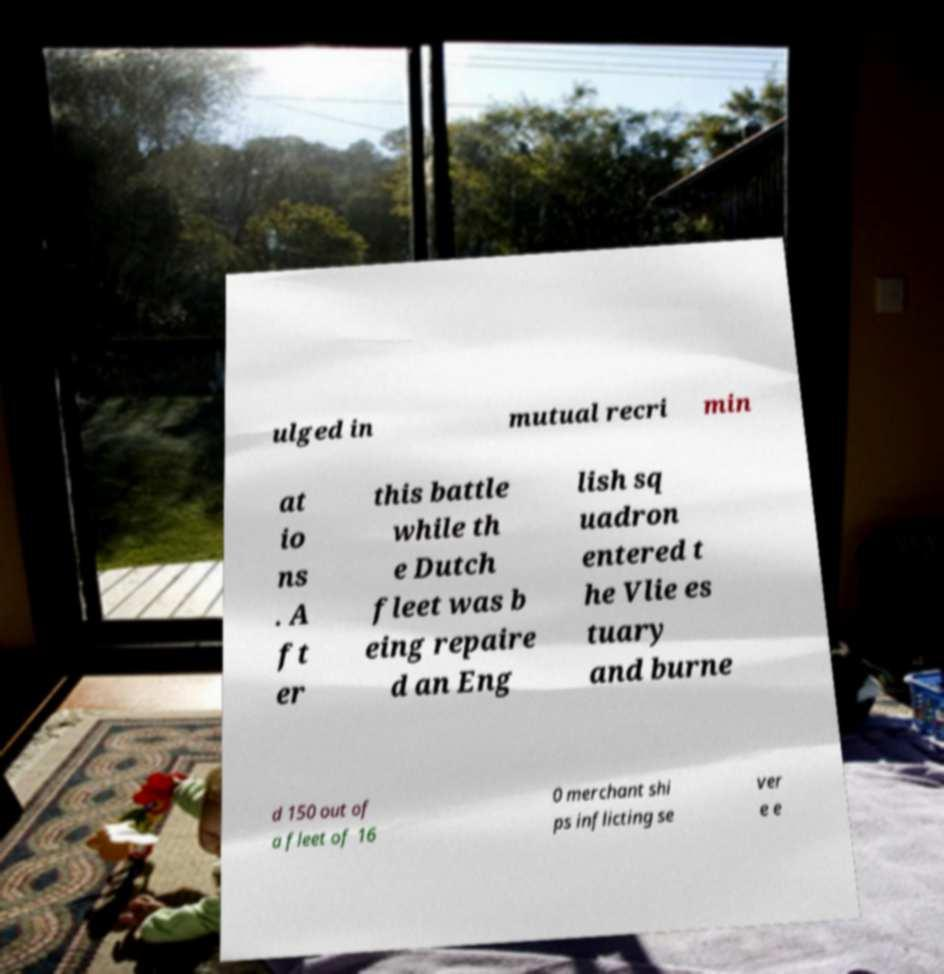Please read and relay the text visible in this image. What does it say? ulged in mutual recri min at io ns . A ft er this battle while th e Dutch fleet was b eing repaire d an Eng lish sq uadron entered t he Vlie es tuary and burne d 150 out of a fleet of 16 0 merchant shi ps inflicting se ver e e 